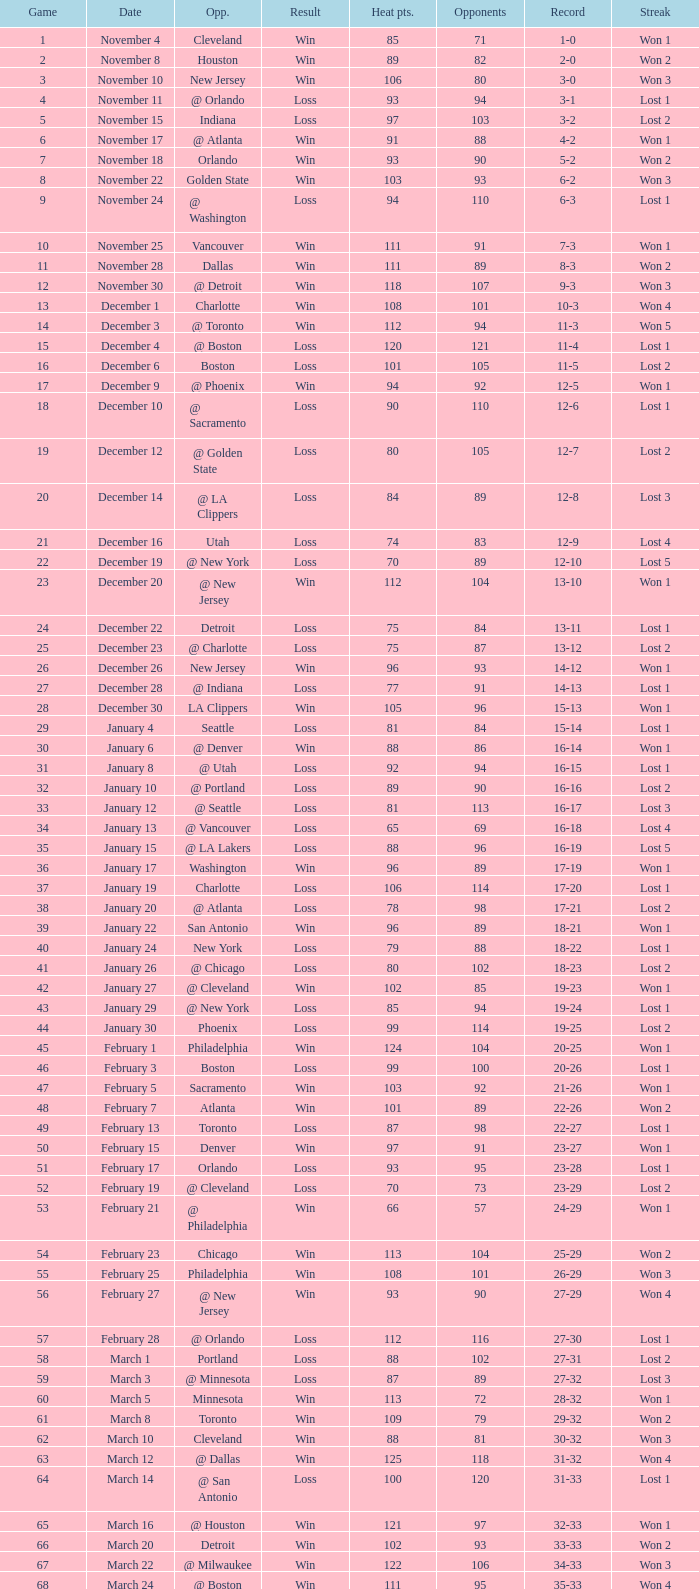What is Result, when Date is "December 12"? Loss. 